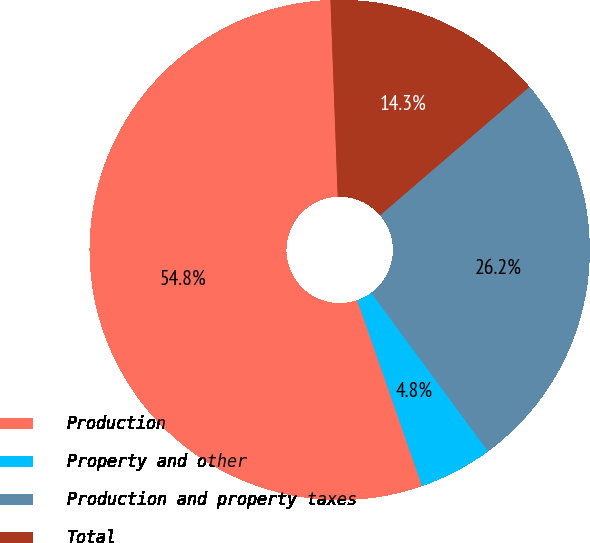Convert chart to OTSL. <chart><loc_0><loc_0><loc_500><loc_500><pie_chart><fcel>Production<fcel>Property and other<fcel>Production and property taxes<fcel>Total<nl><fcel>54.76%<fcel>4.76%<fcel>26.19%<fcel>14.29%<nl></chart> 